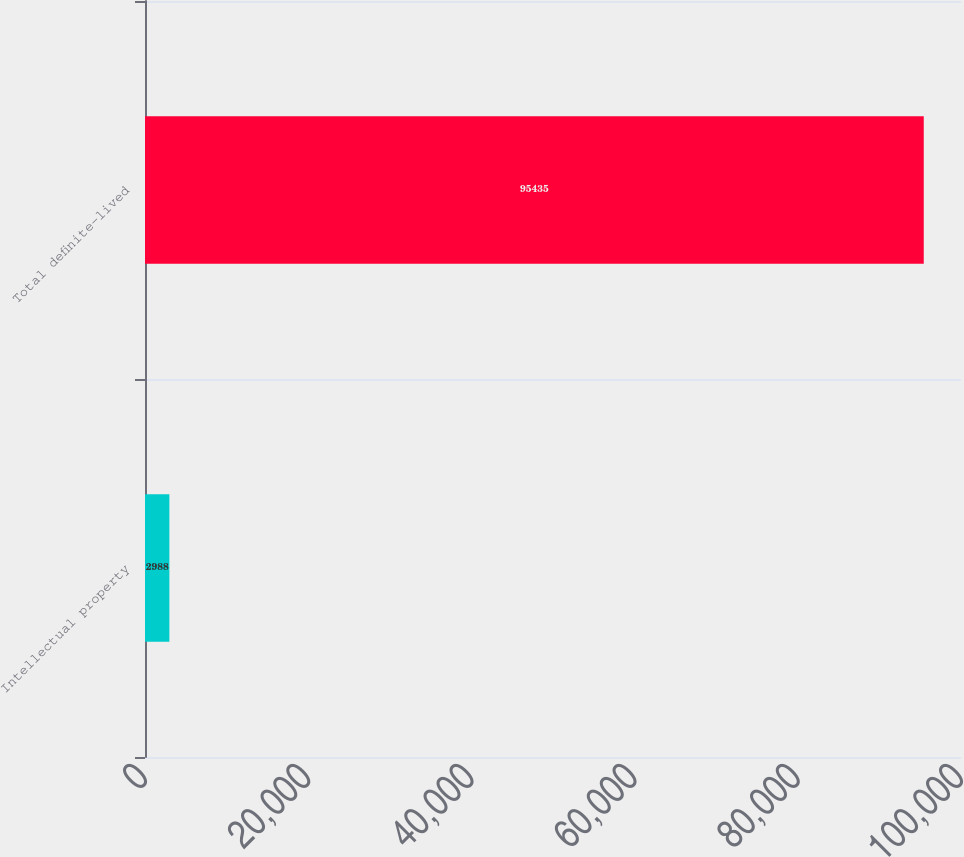Convert chart to OTSL. <chart><loc_0><loc_0><loc_500><loc_500><bar_chart><fcel>Intellectual property<fcel>Total definite-lived<nl><fcel>2988<fcel>95435<nl></chart> 